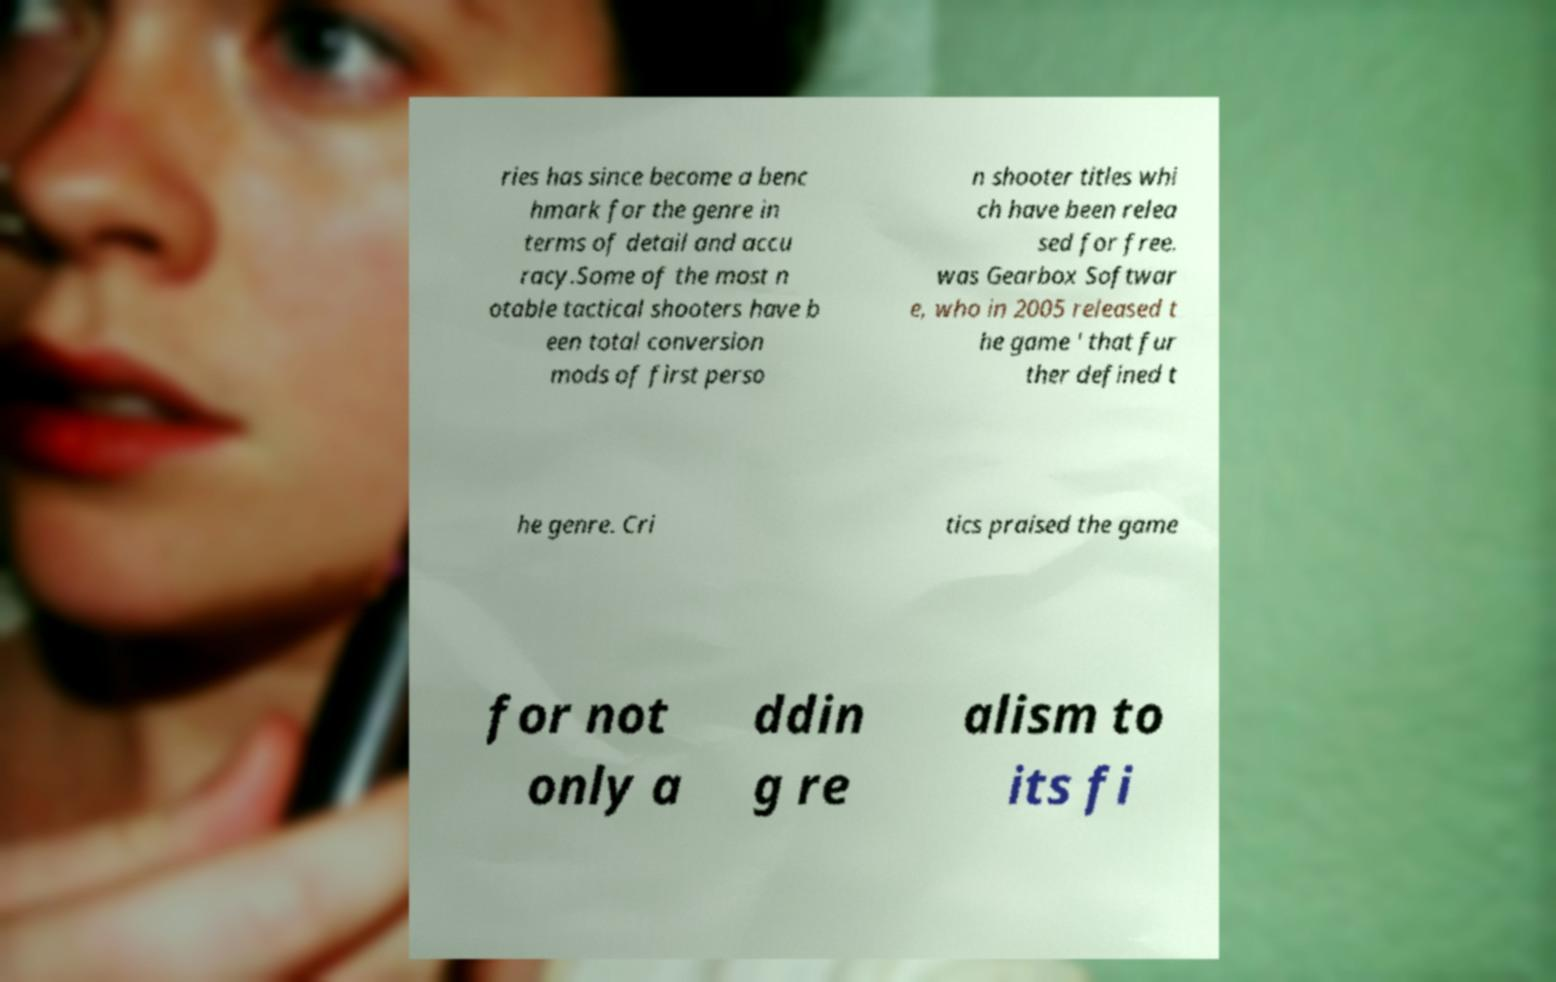Can you accurately transcribe the text from the provided image for me? ries has since become a benc hmark for the genre in terms of detail and accu racy.Some of the most n otable tactical shooters have b een total conversion mods of first perso n shooter titles whi ch have been relea sed for free. was Gearbox Softwar e, who in 2005 released t he game ' that fur ther defined t he genre. Cri tics praised the game for not only a ddin g re alism to its fi 